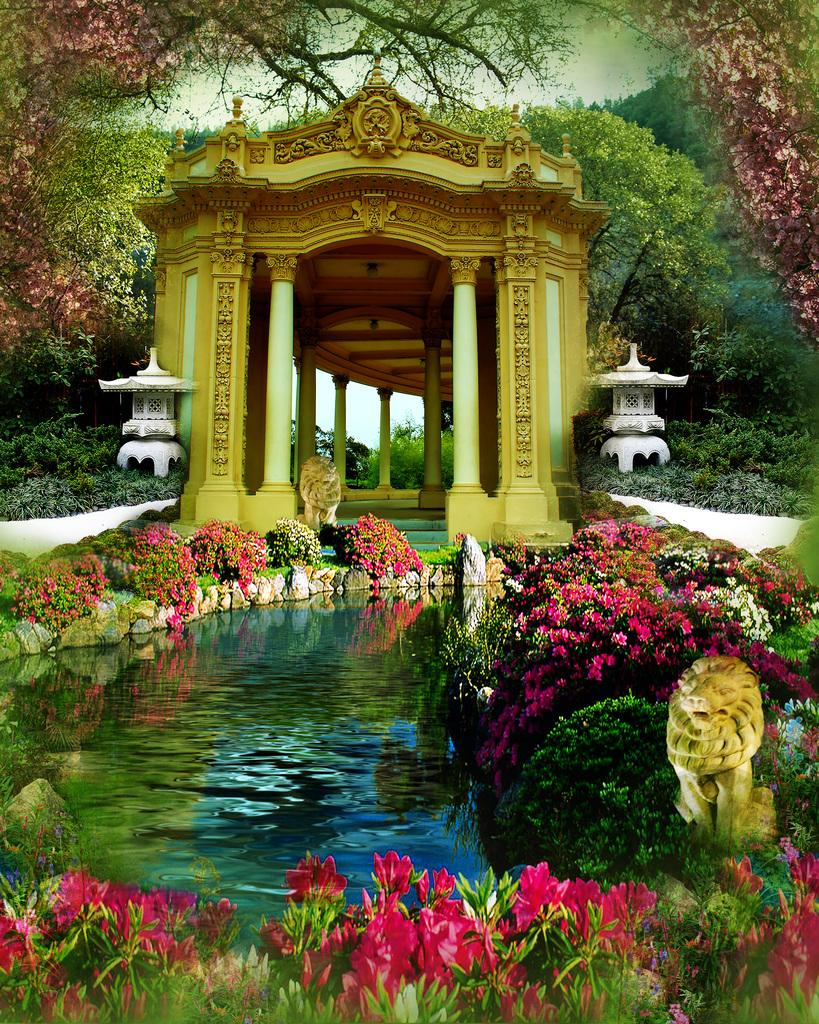What type of water body is present in the image? There is a pond in the image. What can be found around the pond? There are flower plants around the pond. What architectural feature is visible in the image? There is an arch in the image. What supports the arch? There are pillars in front of the arch. What type of sign can be seen hanging from the arch in the image? There is no sign present in the image; only the pond, flower plants, arch, and pillars are visible. 